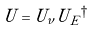Convert formula to latex. <formula><loc_0><loc_0><loc_500><loc_500>U = U _ { \nu } U { _ { E } } ^ { \dagger }</formula> 